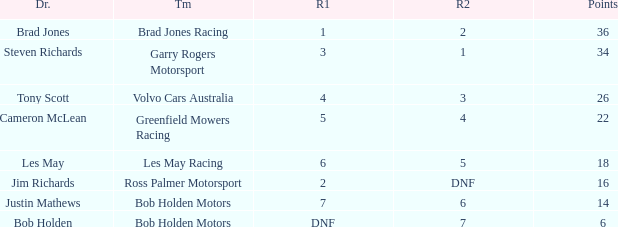Which team received 4 in race 1? Volvo Cars Australia. 